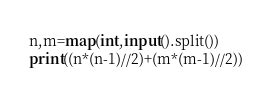Convert code to text. <code><loc_0><loc_0><loc_500><loc_500><_Python_>n,m=map(int,input().split())
print((n*(n-1)//2)+(m*(m-1)//2))</code> 